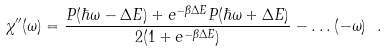<formula> <loc_0><loc_0><loc_500><loc_500>\chi ^ { \prime \prime } ( \omega ) = \frac { P ( \hbar { \omega } - \Delta E ) + e ^ { - \beta \Delta E } P ( \hbar { \omega } + \Delta E ) } { 2 ( 1 + e ^ { - \beta \Delta E } ) } - \dots ( - \omega ) \ .</formula> 